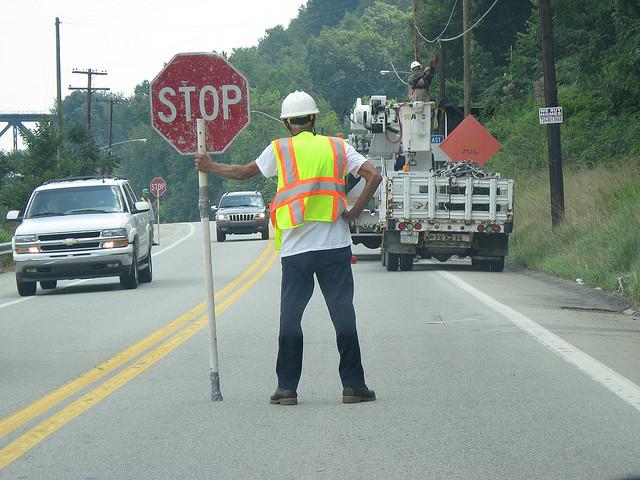What must the cars do when they see the man?
Answer briefly. Stop. Is there a buffet in the image?
Short answer required. No. Is there a horse painting behind the truck?
Keep it brief. No. What does the red sign say?
Concise answer only. Stop. What type of wire is the man working on?
Concise answer only. Telephone. 